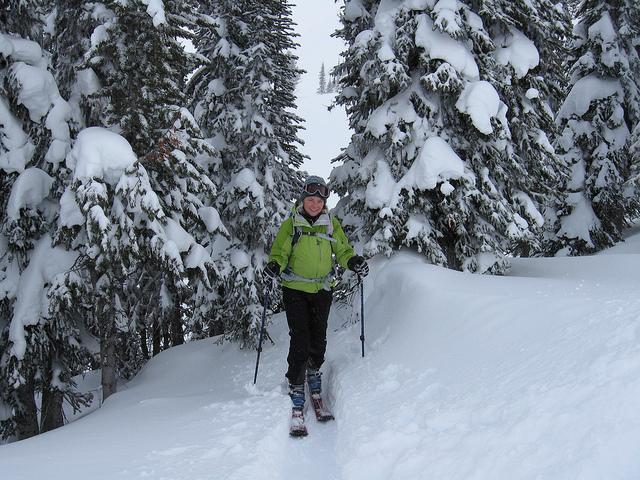How many cups are there?
Give a very brief answer. 0. 